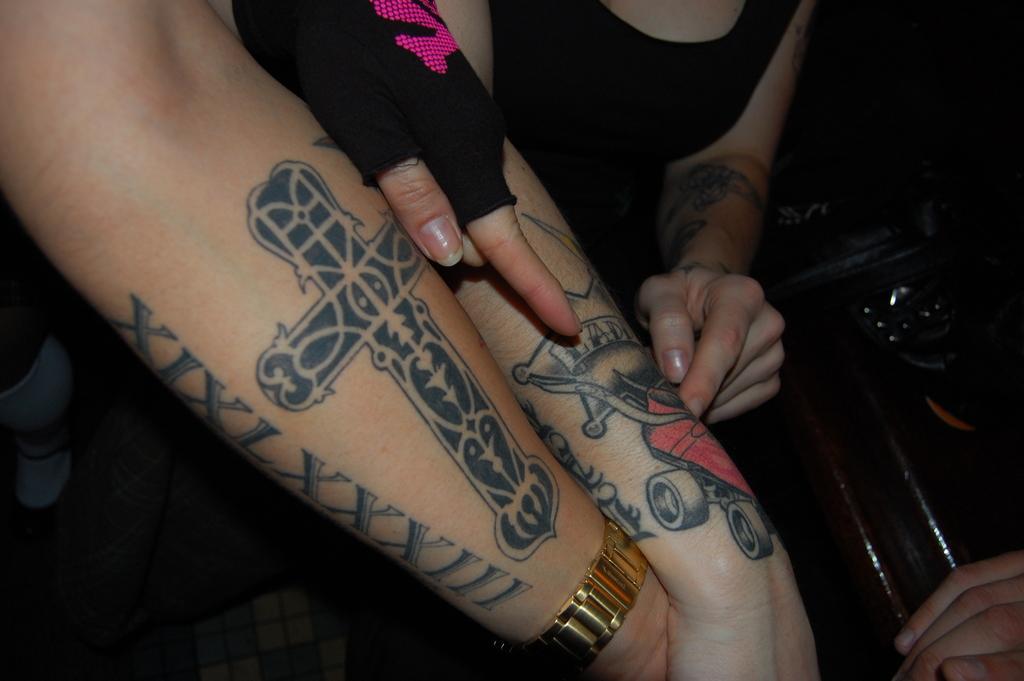How would you summarize this image in a sentence or two? In the image I can see two hands on which there are some tattoos and a watch. 